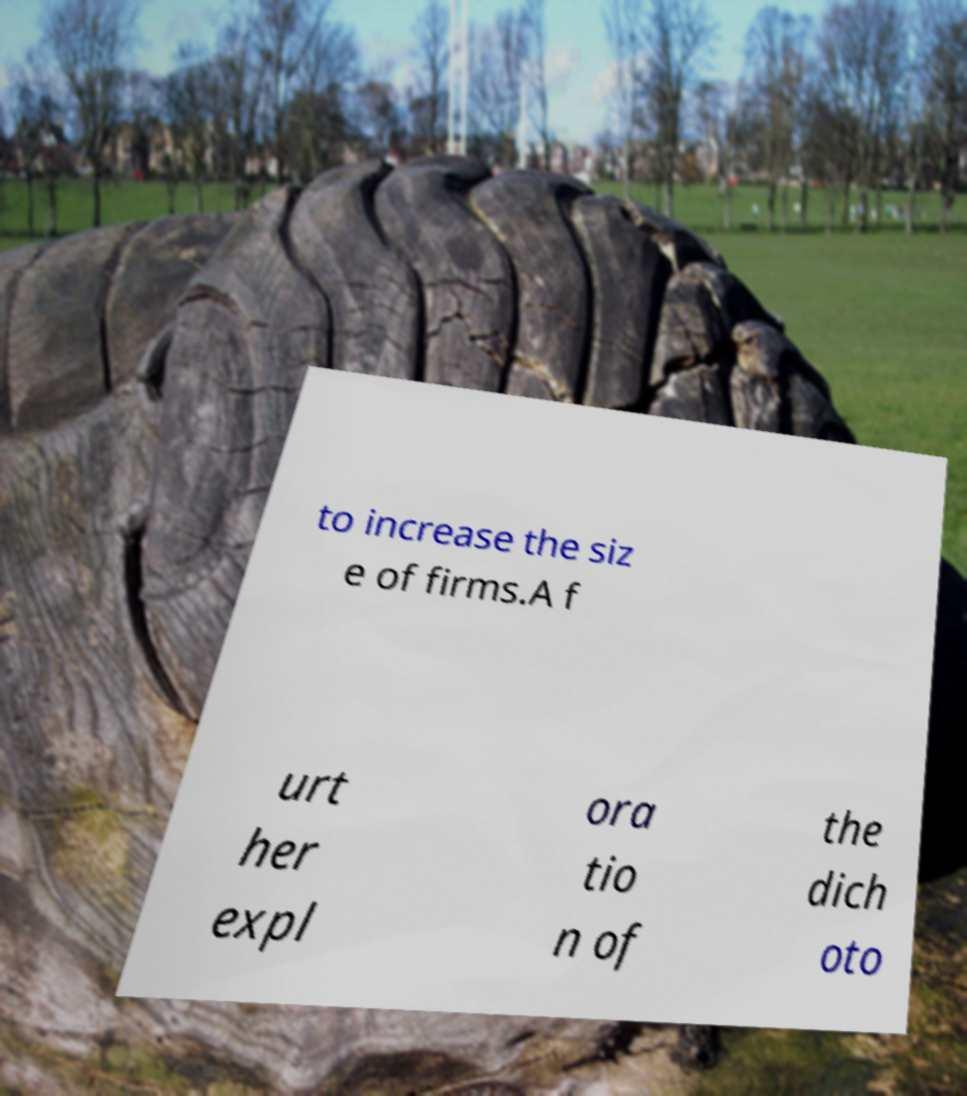For documentation purposes, I need the text within this image transcribed. Could you provide that? to increase the siz e of firms.A f urt her expl ora tio n of the dich oto 